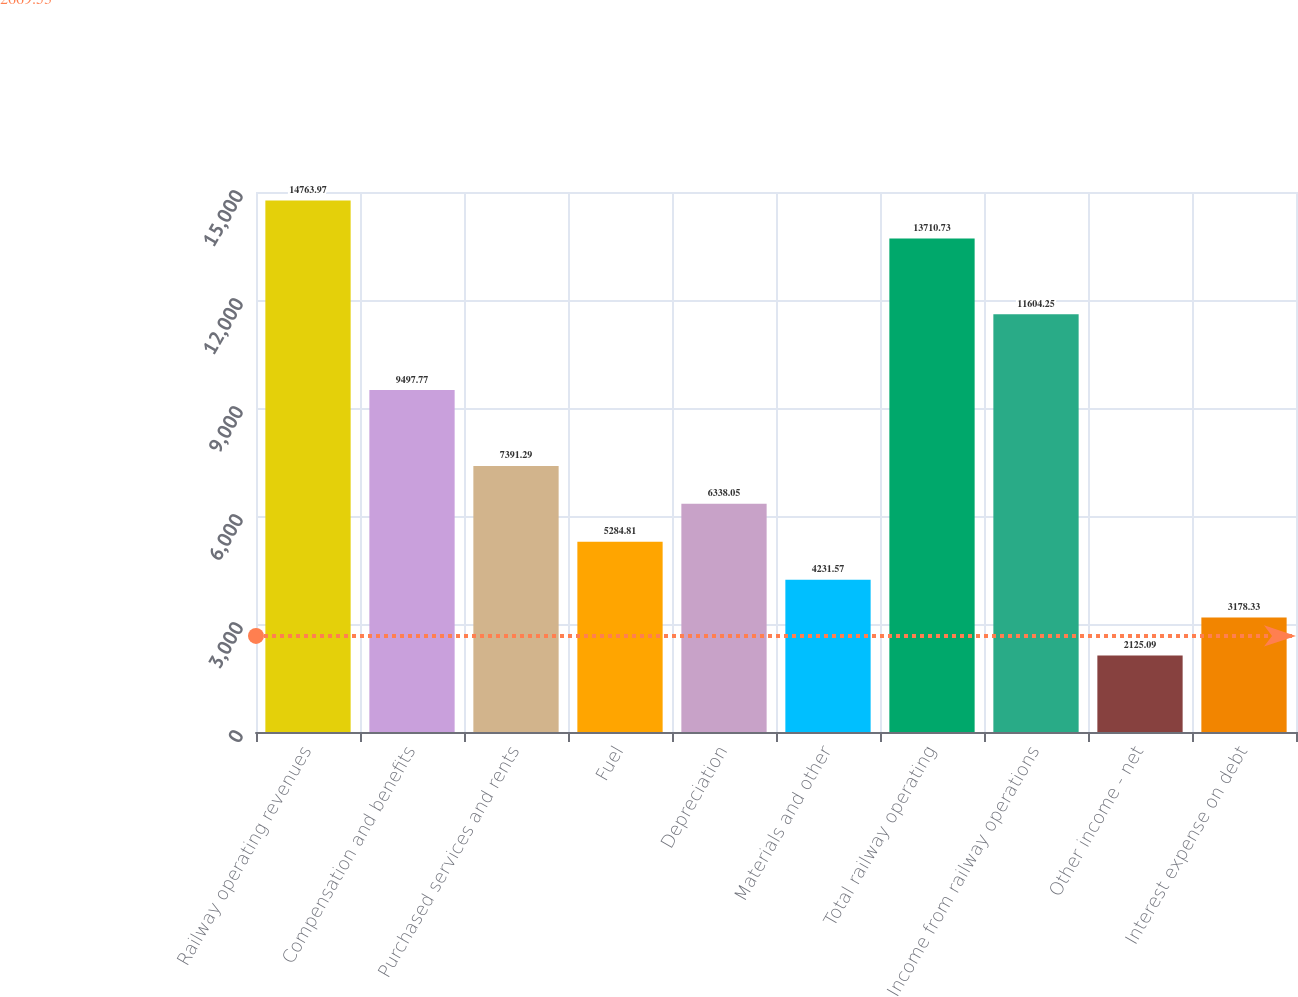<chart> <loc_0><loc_0><loc_500><loc_500><bar_chart><fcel>Railway operating revenues<fcel>Compensation and benefits<fcel>Purchased services and rents<fcel>Fuel<fcel>Depreciation<fcel>Materials and other<fcel>Total railway operating<fcel>Income from railway operations<fcel>Other income - net<fcel>Interest expense on debt<nl><fcel>14764<fcel>9497.77<fcel>7391.29<fcel>5284.81<fcel>6338.05<fcel>4231.57<fcel>13710.7<fcel>11604.2<fcel>2125.09<fcel>3178.33<nl></chart> 